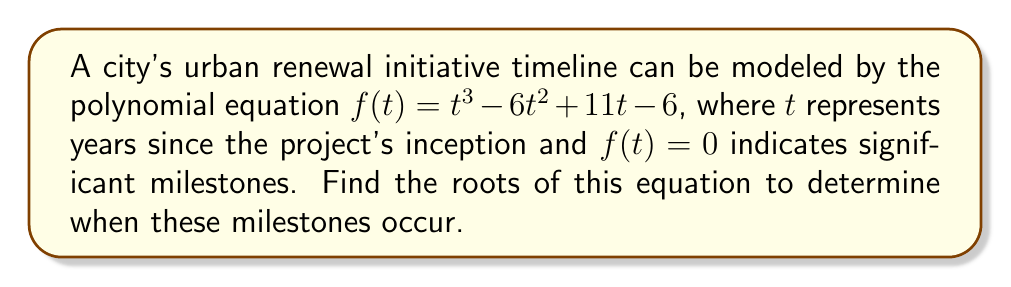Teach me how to tackle this problem. To find the roots of the polynomial equation $f(t) = t^3 - 6t^2 + 11t - 6$, we need to factor it.

Step 1: Check for rational roots using the rational root theorem.
Possible rational roots: $\pm 1, \pm 2, \pm 3, \pm 6$

Step 2: Use synthetic division to test these roots.
Testing $t = 1$:
$$
\begin{array}{r|r}
1 & 1 \quad -6 \quad 11 \quad -6 \\
& 1 \quad -5 \quad 6 \\
\hline
1 & 1 \quad -5 \quad 6 \quad 0
\end{array}
$$

We find that $t = 1$ is a root.

Step 3: Factor out $(t - 1)$:
$f(t) = (t - 1)(t^2 - 5t + 6)$

Step 4: Use the quadratic formula to solve $t^2 - 5t + 6 = 0$
$t = \frac{5 \pm \sqrt{25 - 24}}{2} = \frac{5 \pm 1}{2}$

This gives us the other two roots: $t = 3$ and $t = 2$

Therefore, the roots of the equation are $t = 1$, $t = 2$, and $t = 3$.
Answer: $t = 1, 2, 3$ 